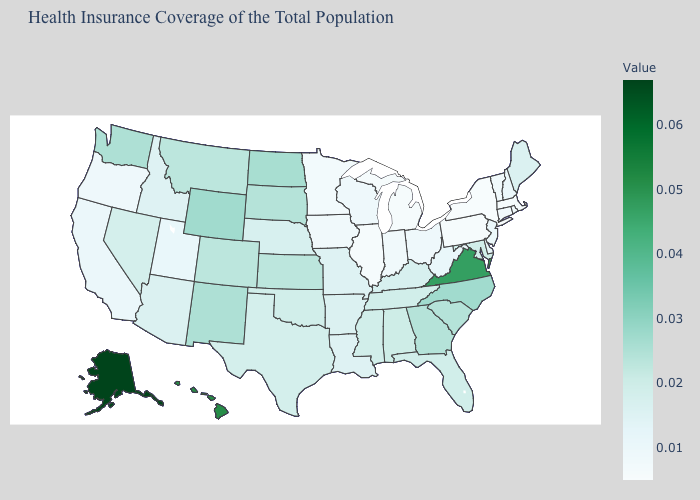Which states hav the highest value in the West?
Quick response, please. Alaska. Does Utah have the highest value in the West?
Concise answer only. No. Among the states that border Indiana , which have the lowest value?
Concise answer only. Illinois, Michigan. Which states hav the highest value in the MidWest?
Write a very short answer. North Dakota. Does Nebraska have the highest value in the USA?
Concise answer only. No. 